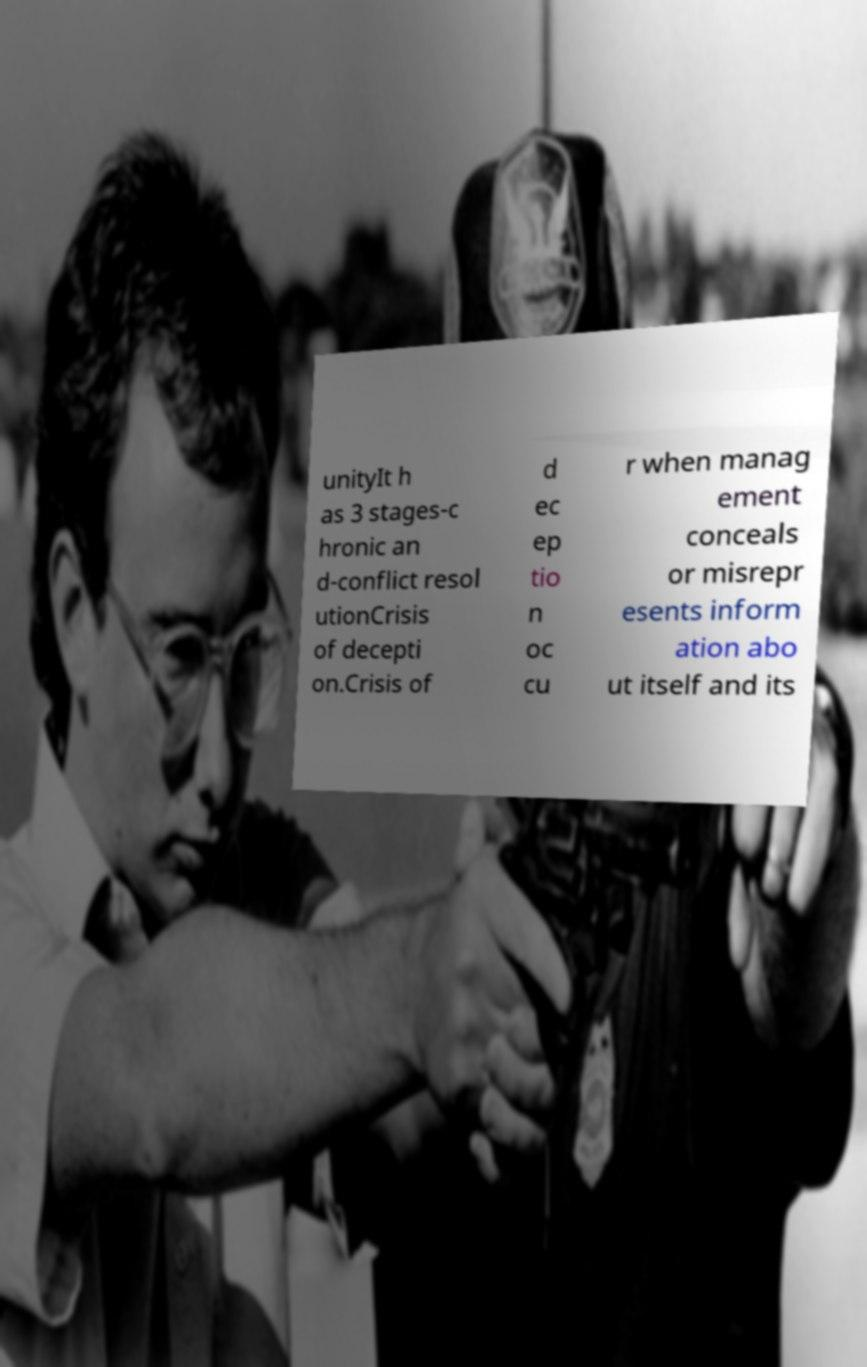Can you read and provide the text displayed in the image?This photo seems to have some interesting text. Can you extract and type it out for me? unityIt h as 3 stages-c hronic an d-conflict resol utionCrisis of decepti on.Crisis of d ec ep tio n oc cu r when manag ement conceals or misrepr esents inform ation abo ut itself and its 